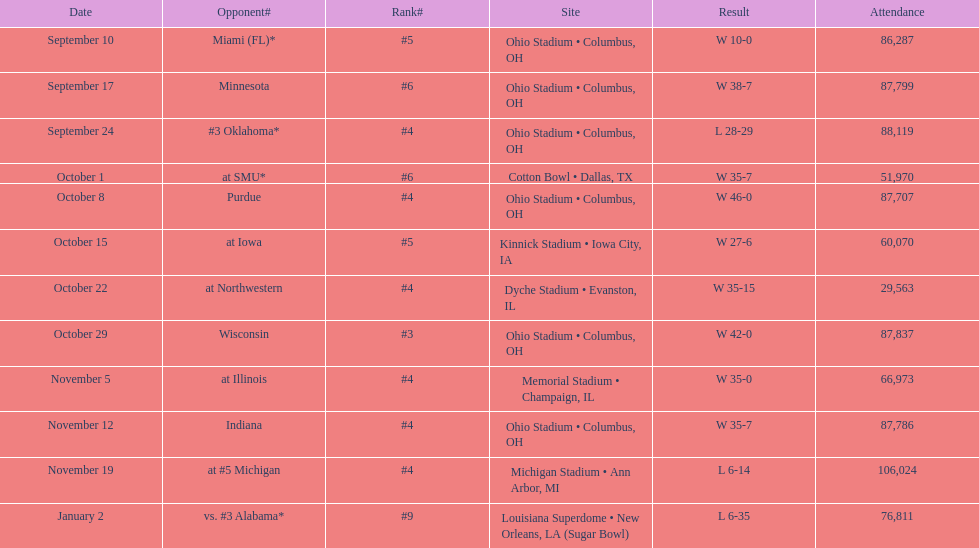On which date did the highest number of people attend? November 19. 